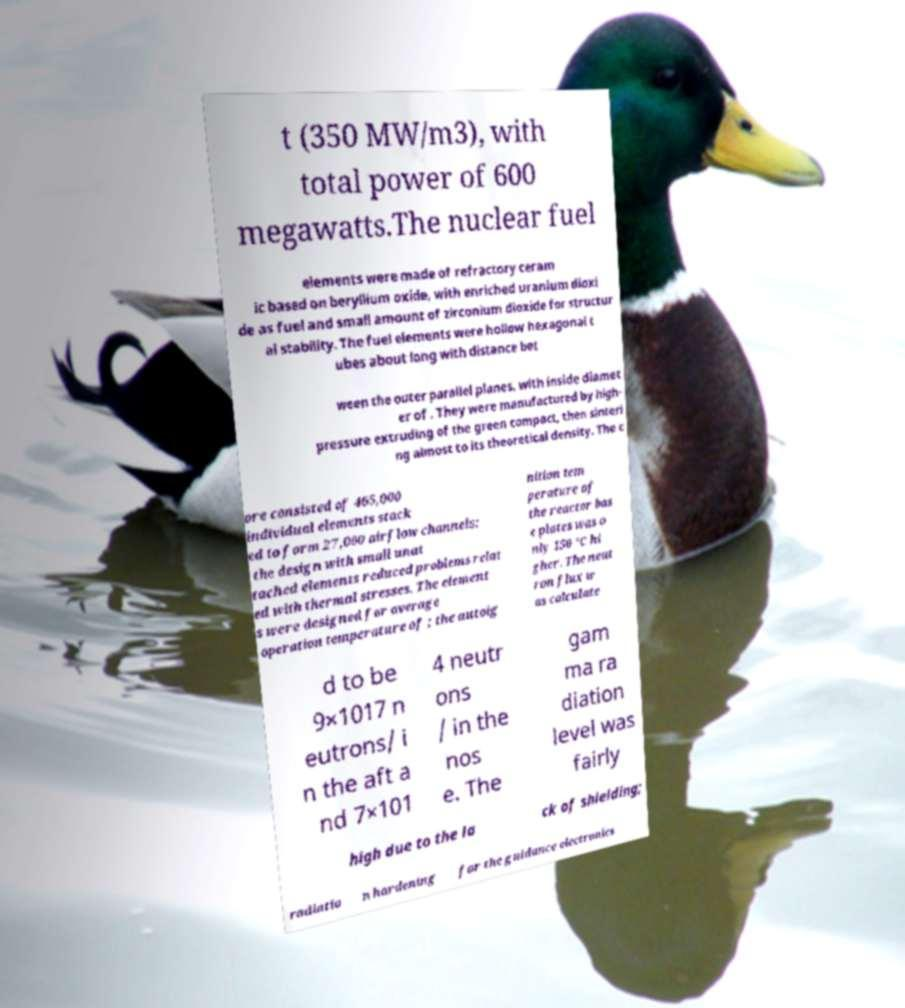There's text embedded in this image that I need extracted. Can you transcribe it verbatim? t (350 MW/m3), with total power of 600 megawatts.The nuclear fuel elements were made of refractory ceram ic based on beryllium oxide, with enriched uranium dioxi de as fuel and small amount of zirconium dioxide for structur al stability. The fuel elements were hollow hexagonal t ubes about long with distance bet ween the outer parallel planes, with inside diamet er of . They were manufactured by high- pressure extruding of the green compact, then sinteri ng almost to its theoretical density. The c ore consisted of 465,000 individual elements stack ed to form 27,000 airflow channels; the design with small unat tached elements reduced problems relat ed with thermal stresses. The element s were designed for average operation temperature of ; the autoig nition tem perature of the reactor bas e plates was o nly 150 °C hi gher. The neut ron flux w as calculate d to be 9×1017 n eutrons/ i n the aft a nd 7×101 4 neutr ons / in the nos e. The gam ma ra diation level was fairly high due to the la ck of shielding; radiatio n hardening for the guidance electronics 